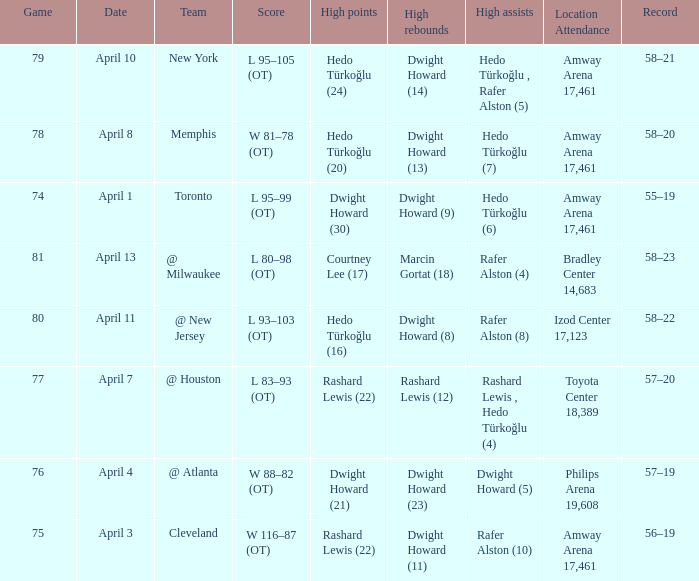Which player had the highest points in game 79? Hedo Türkoğlu (24). 